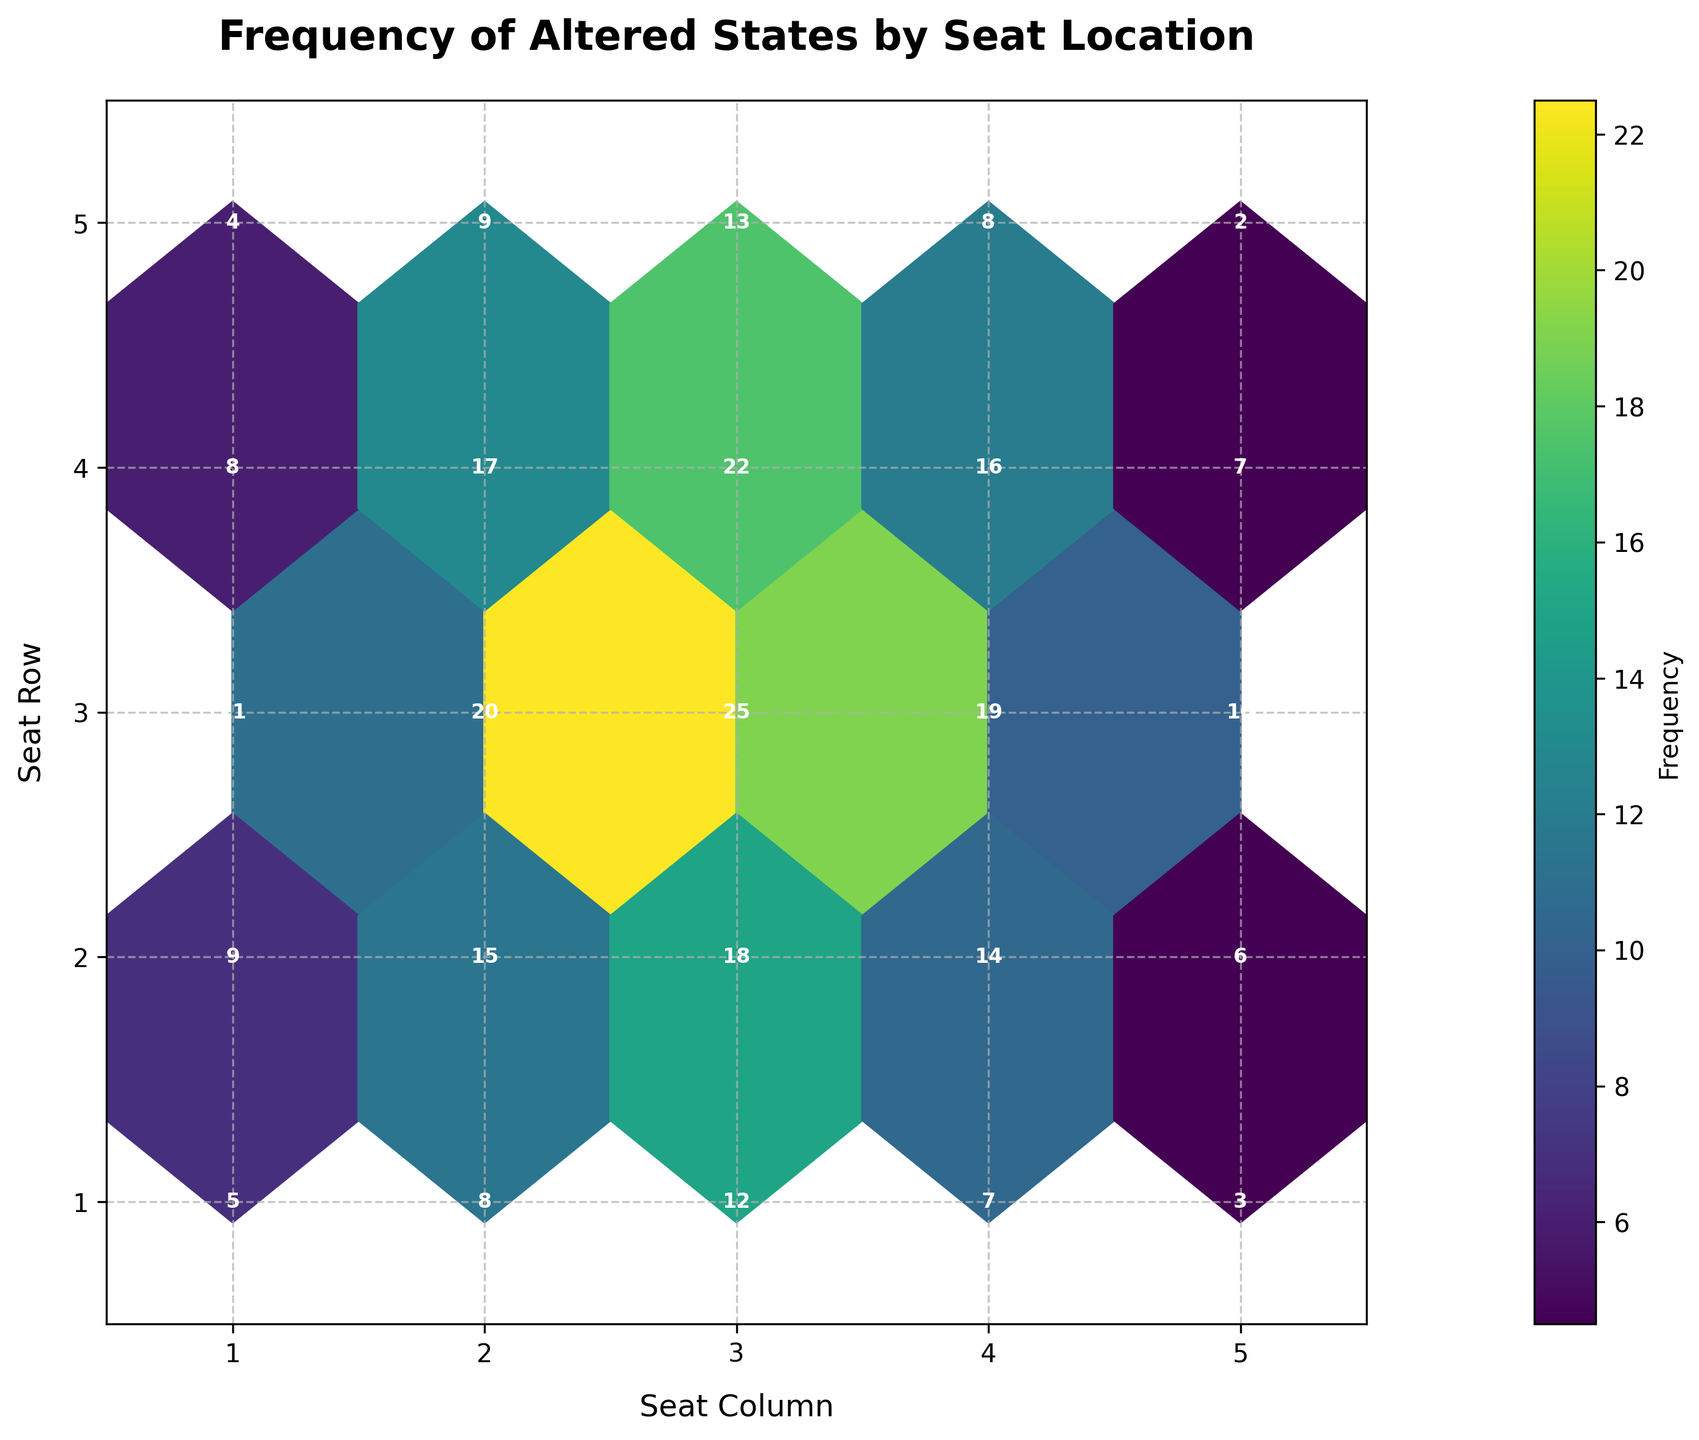Is there a specific color scheme used in the plot? The color scheme used in the plot is specifically 'viridis', which features shades transitioning from purple to yellow meant to indicate varying frequencies.
Answer: viridis What is the title of the plot? The title of the plot is explicitly mentioned in the figure as "Frequency of Altered States by Seat Location".
Answer: Frequency of Altered States by Seat Location Which seat has the highest frequency of altered states of consciousness reported? By inspecting the value annotations on each hexbin, the frequency value 25 is the highest, and it is located at seat (3,3).
Answer: seat (3,3) How many seats reported a frequency of altered states greater than 15? By counting the frequency values annotated on each hexbin, the following seats exceed 15: (3,2), (2,3), (3,3), (3,4). Therefore, four seats report a frequency greater than 15.
Answer: 4 seats What range of frequencies is represented on the color bar? The color bar alongside the plot represents the range of frequencies that extend from the minimum value of 2 up to the maximum value of 25.
Answer: 2 to 25 Which seat locations have the lowest frequency of altered states, and what is that frequency? The lowest frequency on the plot is 2, which can be seen on seat (5,5).
Answer: seat (5,5) What is the average frequency of altered states reported in the first row (y=1)? Adding up the frequencies in the first row: 5+8+12+7+3 = 35. Dividing by the number of seats, 35/5 = 7.
Answer: 7 Are there more high-frequency reports in the center seats (columns 2 and 3) compared to the edge seats (columns 1 and 5)? Summing the frequencies for columns 2 and 3: column 2 (8+15+20+17+9)=69, column 3 (12+18+25+22+13)=90, totaling 159. Summing for columns 1 and 5: column 1 (5+9+11+8+4)=37, column 5 (3+6+10+7+2)=28, totaling 65. The central columns (2 and 3) report a much higher frequency (159) than the edge columns (1 and 5) (65).
Answer: Yes, center seats report more Comparing row 3 and row 5, which row shows a higher total frequency of altered states? Summing the frequencies for each row: row 3 (11+20+25+19+10)=85, row 5 (4+9+13+8+2)=36. Therefore, row 3 shows a higher total frequency of 85 compared to row 5's 36.
Answer: Row 3 has higher frequency 